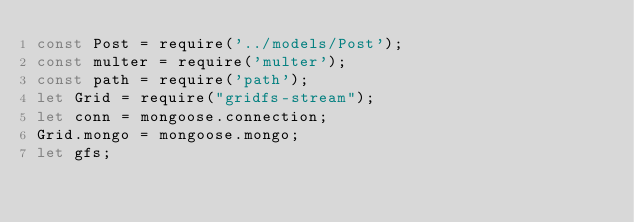<code> <loc_0><loc_0><loc_500><loc_500><_JavaScript_>const Post = require('../models/Post');
const multer = require('multer');
const path = require('path');
let Grid = require("gridfs-stream");
let conn = mongoose.connection;
Grid.mongo = mongoose.mongo;
let gfs;
</code> 